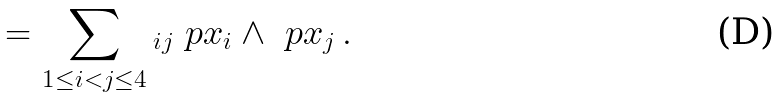Convert formula to latex. <formula><loc_0><loc_0><loc_500><loc_500>\L = \sum _ { 1 \leq i < j \leq 4 } \L _ { i j } \ p { x _ { i } } \wedge \ p { x _ { j } } \, .</formula> 